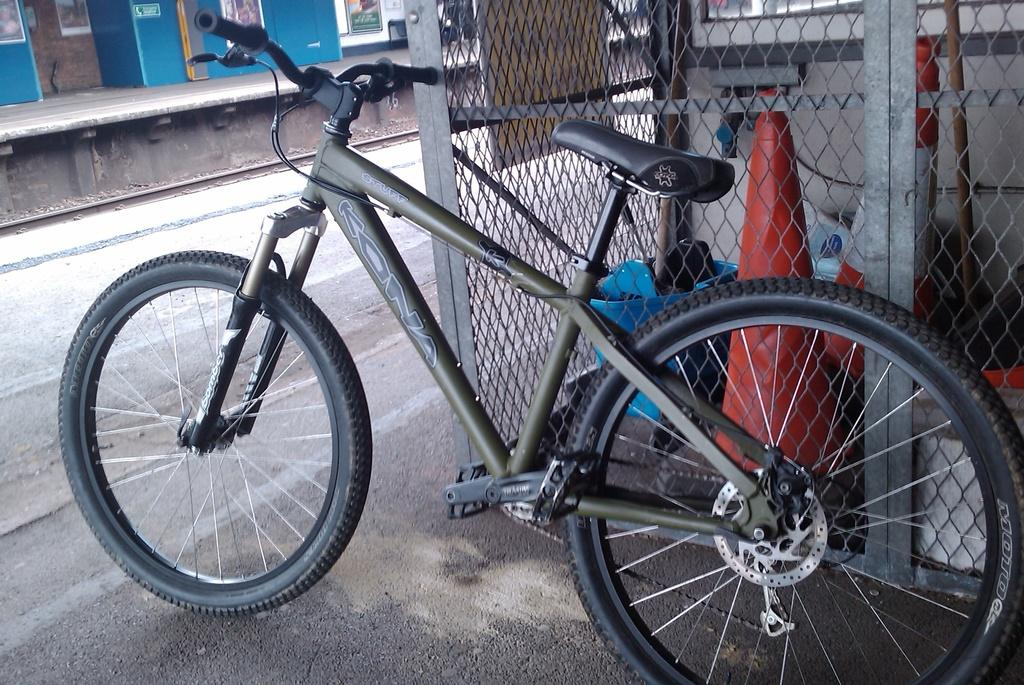What type of vehicle is in the image? There is a green bicycle in the image. What can be seen in the background of the image? There is fencing, a traffic cone, a road, a platform, and a railway track in the background of the image. Can you describe the platform in the background? The platform is a raised surface, possibly for pedestrians or vehicles to stand on. How many geese are standing on the line in the image? There are no geese or lines present in the image. What type of support is provided by the bicycle in the image? The bicycle in the image is not providing any support, as it is a stationary object. 